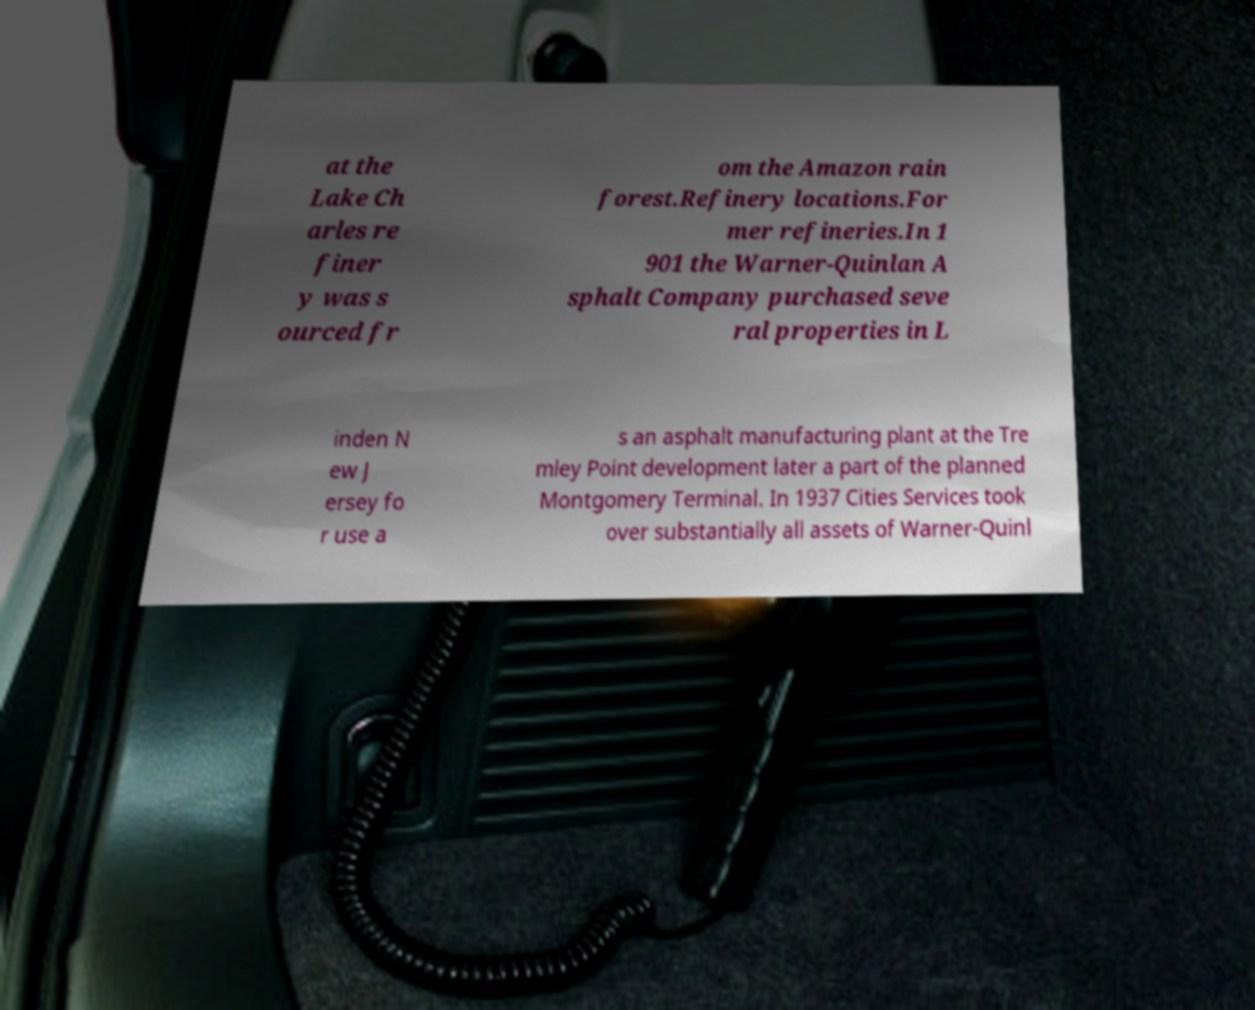I need the written content from this picture converted into text. Can you do that? at the Lake Ch arles re finer y was s ourced fr om the Amazon rain forest.Refinery locations.For mer refineries.In 1 901 the Warner-Quinlan A sphalt Company purchased seve ral properties in L inden N ew J ersey fo r use a s an asphalt manufacturing plant at the Tre mley Point development later a part of the planned Montgomery Terminal. In 1937 Cities Services took over substantially all assets of Warner-Quinl 